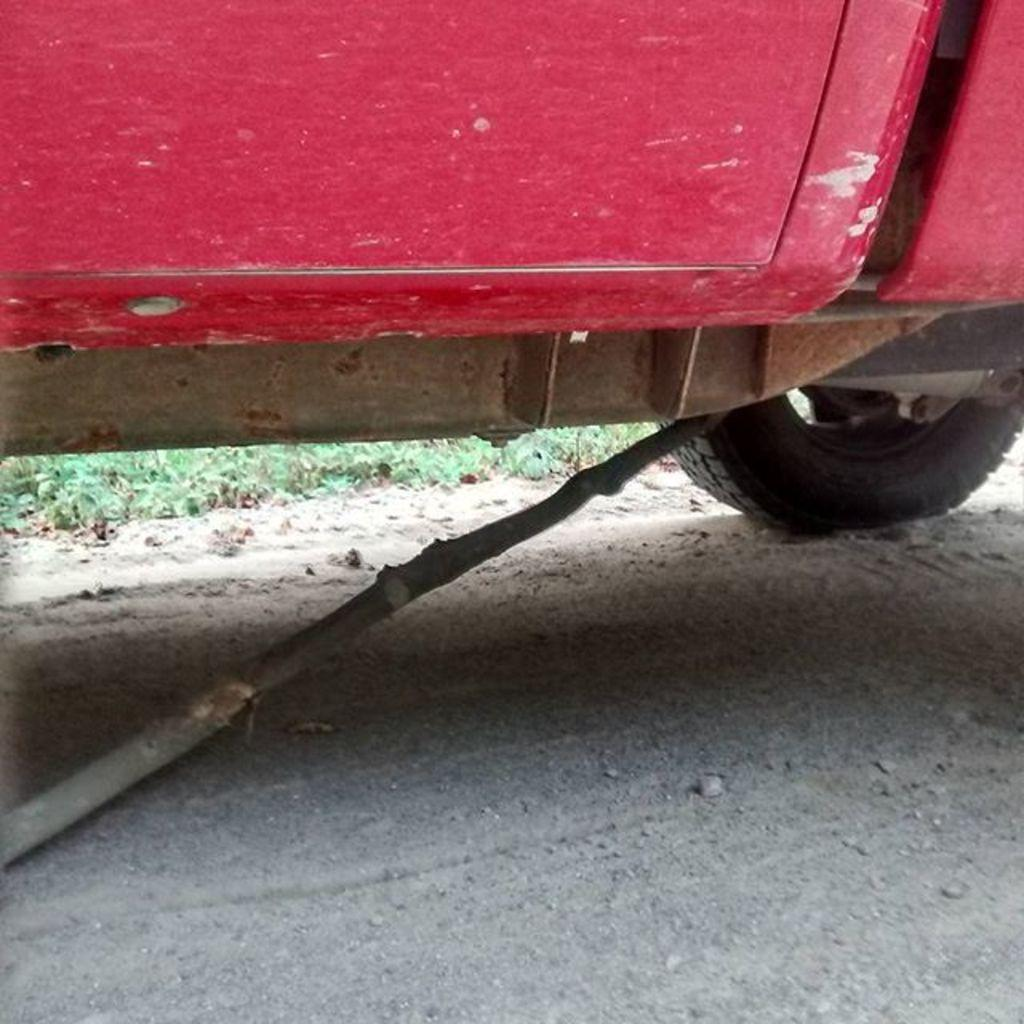What is the main object in the image? There is a vehicle in the image. What is the purpose of the stick in the image? A stick is placed under the vehicle. Where are the vehicle and stick located? The vehicle and stick are on the ground. What type of terrain is visible in the image? There is grass visible in the image. What type of bean is being examined by the doctor in the image? There is no bean or doctor present in the image; it features a vehicle with a stick under it on grass. 